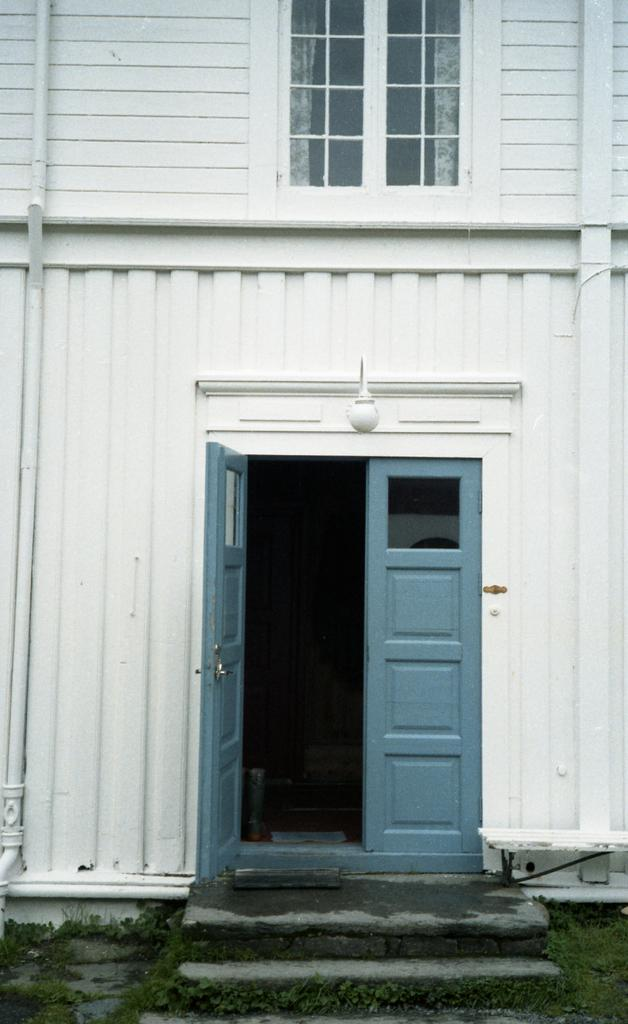What type of structure is visible in the image? There is a building in the image. Can you describe any specific features of the building? There is a window, curtains, doors, steps, and a wall visible in the image. What is the building's exterior environment like? There is grass in the image, suggesting that the building is located in a natural setting. Are there any other objects or elements in the image? Yes, there are some unspecified objects in the image. How much debt is the building in the image currently facing? There is no information about the building's financial status in the image, so it is impossible to determine its debt. --- Facts: 1. There is a person in the image. 2. The person is wearing a hat. 3. The person is holding a book. 4. There is a table in the image. 5. The table has a lamp on it. 6. There is a chair next to the table. Absurd Topics: parrot, volcano, ocean Conversation: What is the main subject of the image? There is a person in the image. Can you describe the person's attire? The person is wearing a hat. What is the person holding in the image? The person is holding a book. What furniture is visible in the image? There is a table and a chair in the image. Are there any objects on the table? Yes, there is a lamp on the table. Reasoning: Let's think step by step in order to produce the conversation. We start by identifying the main subject of the image, which is the person. Then, we describe the person's attire, noting that they are wearing a hat. We also mention the book the person is holding, as it is another important detail in the image. Next, we describe the furniture in the image, which includes a table and a chair. Finally, we mention the lamp on the table, as it is an object that provides additional context about the setting. Absurd Question/Answer: Can you see any parrots flying over the volcano in the image? There is no volcano or parrot present in the image. 